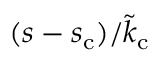<formula> <loc_0><loc_0><loc_500><loc_500>( s - s _ { c } ) / \tilde { k } _ { c }</formula> 